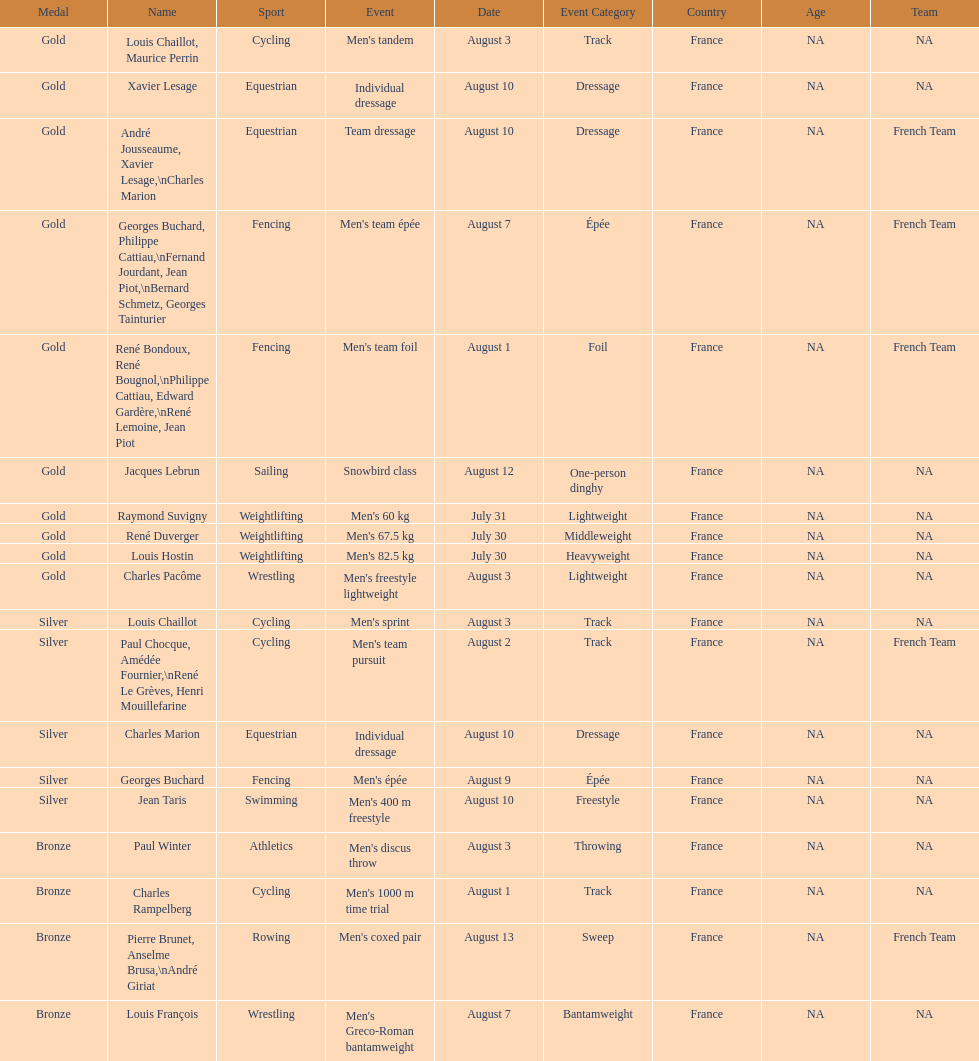How many total gold medals were won by weightlifting? 3. 